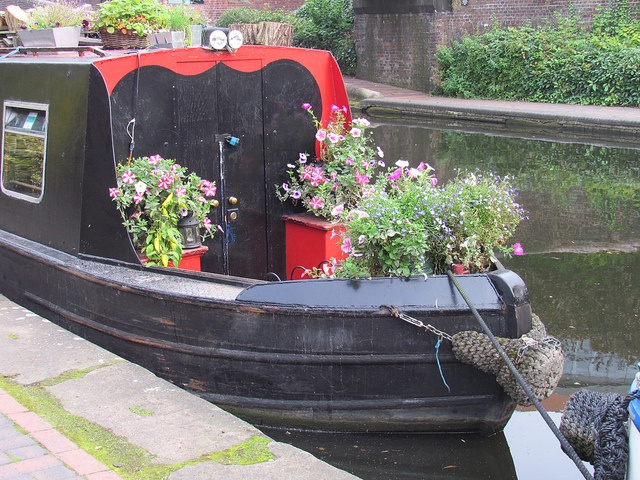Describe the objects in this image and their specific colors. I can see boat in gray, black, and darkgray tones, potted plant in gray, black, lavender, and darkgray tones, potted plant in gray, olive, darkgray, and lightgray tones, potted plant in gray, white, olive, and darkgray tones, and potted plant in gray, green, darkgray, and lightgreen tones in this image. 